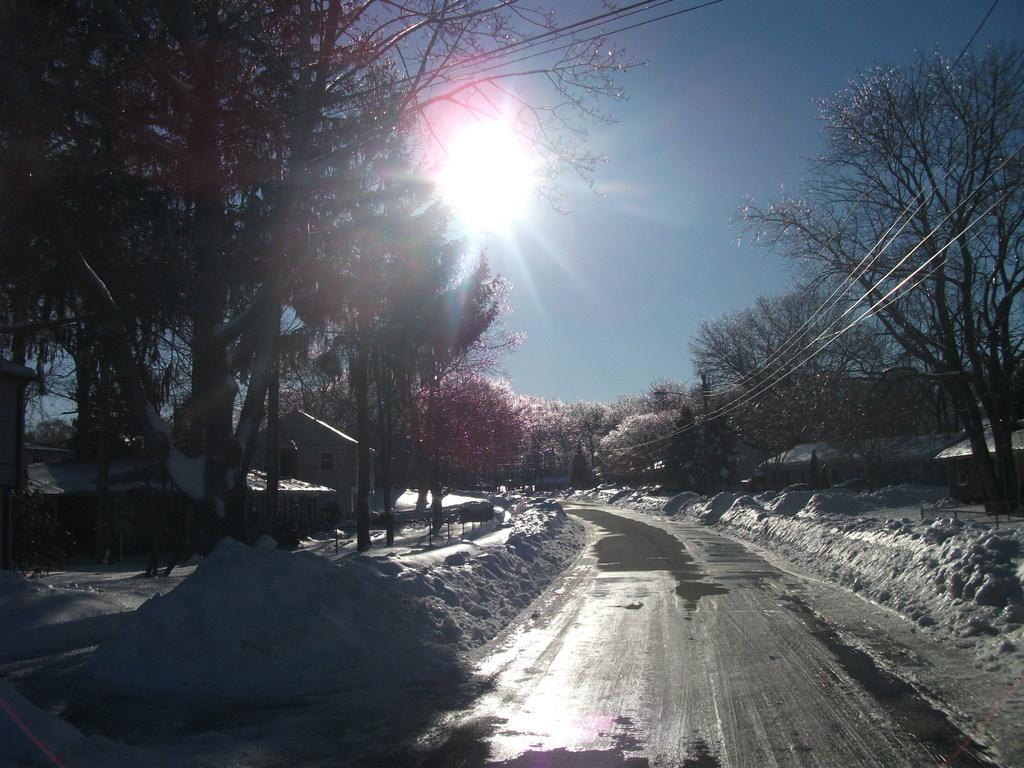What is located at the bottom of the image? There is a way at the bottom of the image. What type of vegetation is present in the image? There are flower trees in the image. What is the weather condition in the image? There is snow on the right and left sides of the image, indicating a cold and snowy environment. What can be seen in the sky in the image? The sun is visible in the sky. What type of cakes are being discussed in the image? There is no discussion of cakes in the image; it features a way, flower trees, snow, and the sun in the sky. 